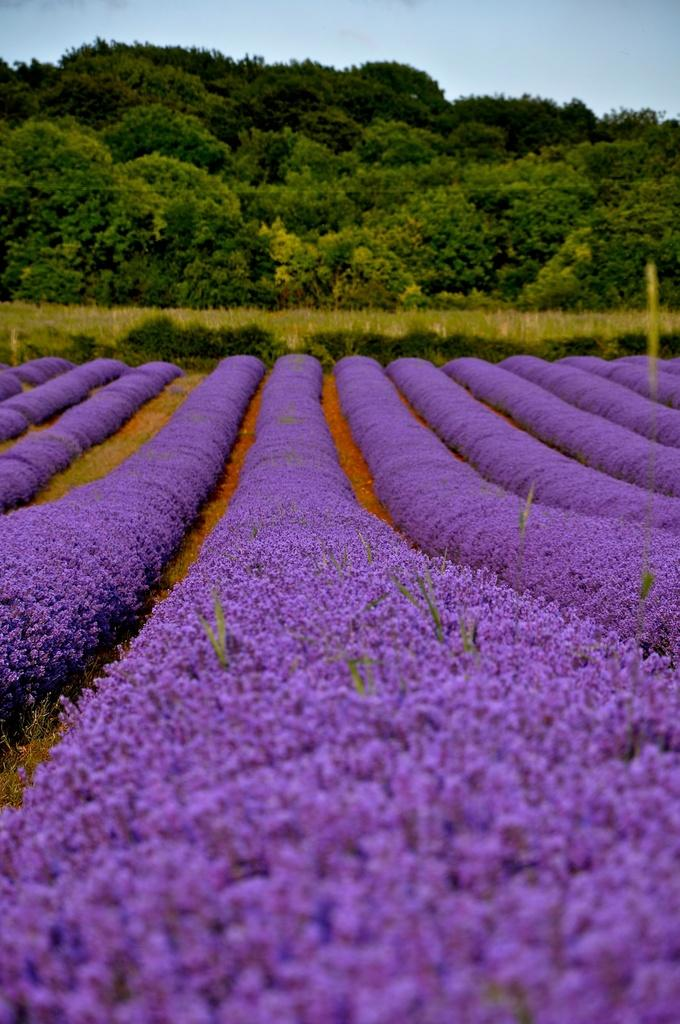What types of plants can be seen in the image? There are many plants with flowers in the image. What else can be seen in the background of the image? There are trees visible in the background of the image. What is visible at the top of the image? The sky is visible at the top of the image. What type of voice can be heard coming from the plants in the image? There is no voice coming from the plants in the image, as plants do not have the ability to produce or emit sounds. 